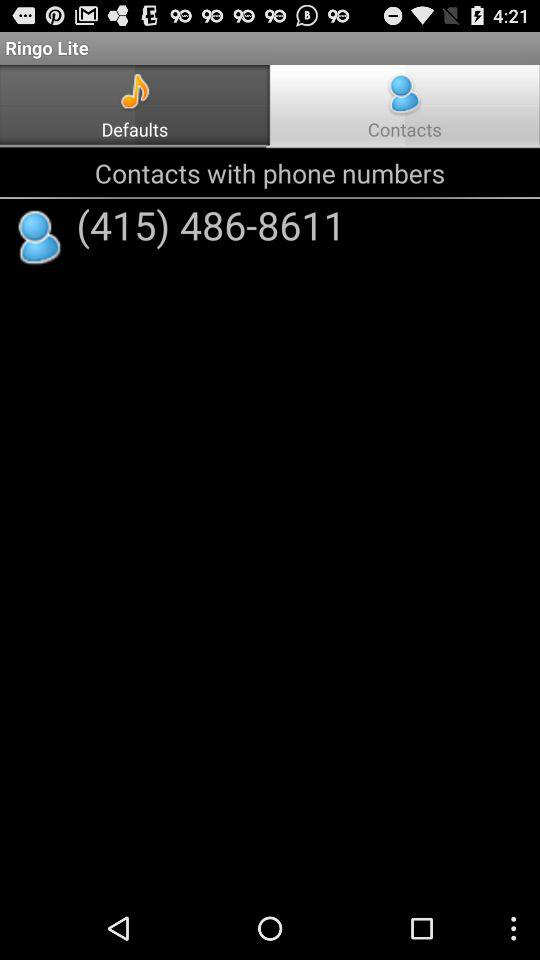What is the contact number? The contact number is (415) 486-8611. 